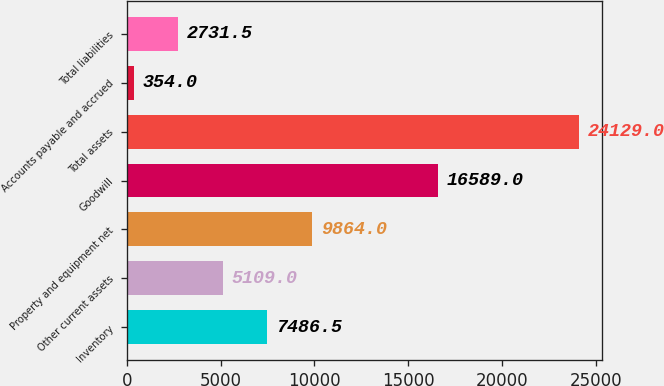<chart> <loc_0><loc_0><loc_500><loc_500><bar_chart><fcel>Inventory<fcel>Other current assets<fcel>Property and equipment net<fcel>Goodwill<fcel>Total assets<fcel>Accounts payable and accrued<fcel>Total liabilities<nl><fcel>7486.5<fcel>5109<fcel>9864<fcel>16589<fcel>24129<fcel>354<fcel>2731.5<nl></chart> 